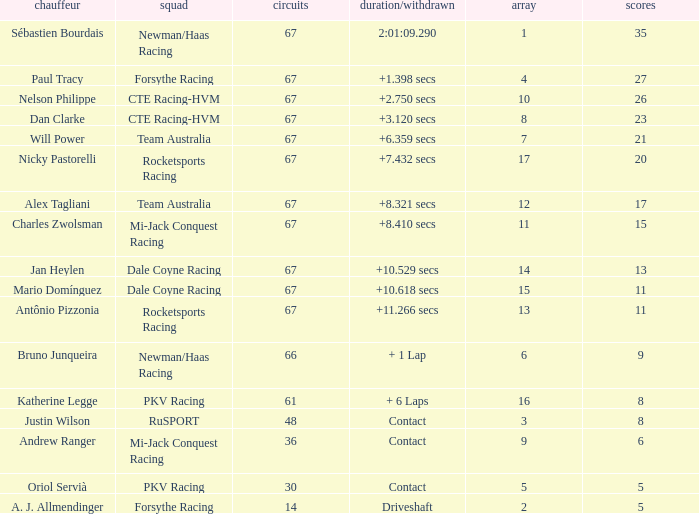How many average laps for Alex Tagliani with more than 17 points? None. 